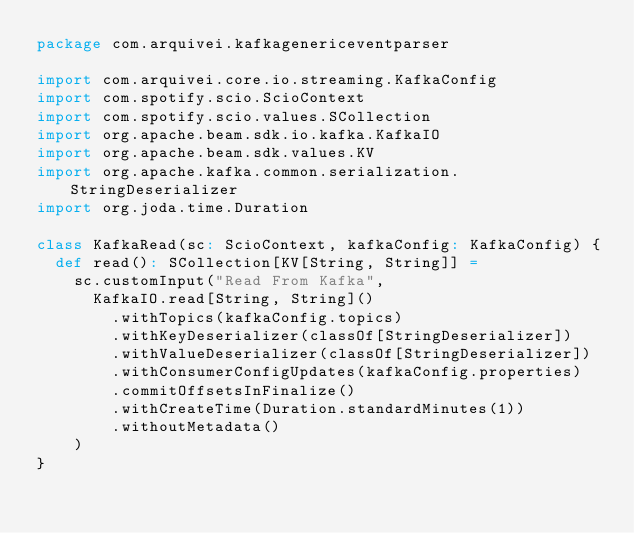Convert code to text. <code><loc_0><loc_0><loc_500><loc_500><_Scala_>package com.arquivei.kafkagenericeventparser

import com.arquivei.core.io.streaming.KafkaConfig
import com.spotify.scio.ScioContext
import com.spotify.scio.values.SCollection
import org.apache.beam.sdk.io.kafka.KafkaIO
import org.apache.beam.sdk.values.KV
import org.apache.kafka.common.serialization.StringDeserializer
import org.joda.time.Duration

class KafkaRead(sc: ScioContext, kafkaConfig: KafkaConfig) {
  def read(): SCollection[KV[String, String]] =
    sc.customInput("Read From Kafka",
      KafkaIO.read[String, String]()
        .withTopics(kafkaConfig.topics)
        .withKeyDeserializer(classOf[StringDeserializer])
        .withValueDeserializer(classOf[StringDeserializer])
        .withConsumerConfigUpdates(kafkaConfig.properties)
        .commitOffsetsInFinalize()
        .withCreateTime(Duration.standardMinutes(1))
        .withoutMetadata()
    )
}
</code> 